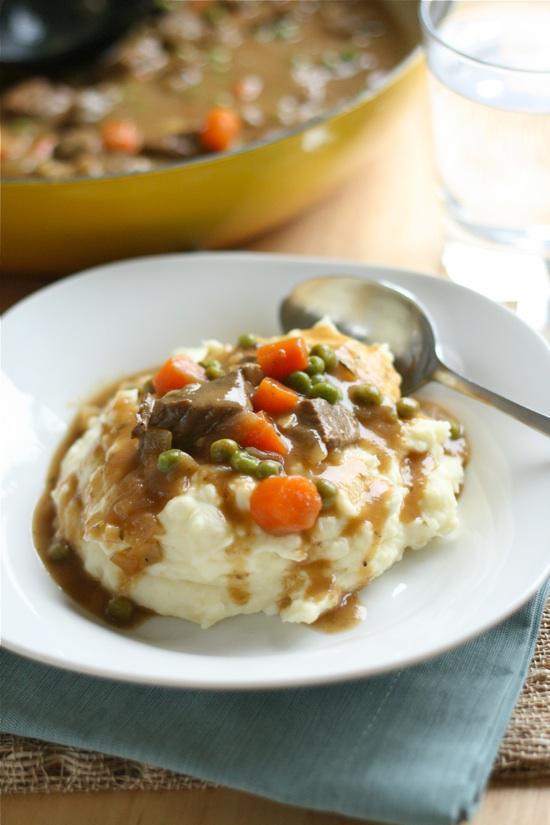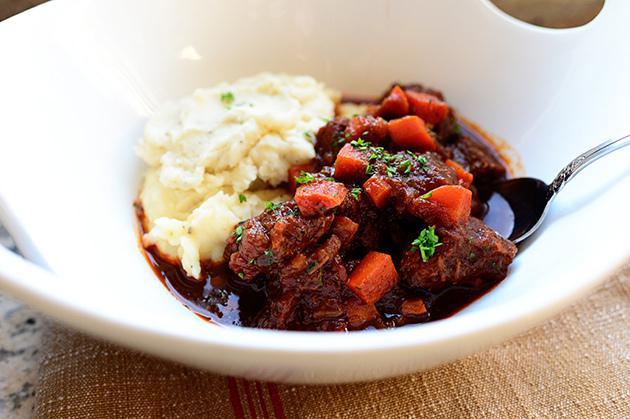The first image is the image on the left, the second image is the image on the right. For the images shown, is this caption "A fork is on the edge of a flower-patterned plate containing beef and gravy garnished with green sprigs." true? Answer yes or no. No. The first image is the image on the left, the second image is the image on the right. For the images displayed, is the sentence "A fork is sitting on the right side of the plate in the image on the right." factually correct? Answer yes or no. No. 